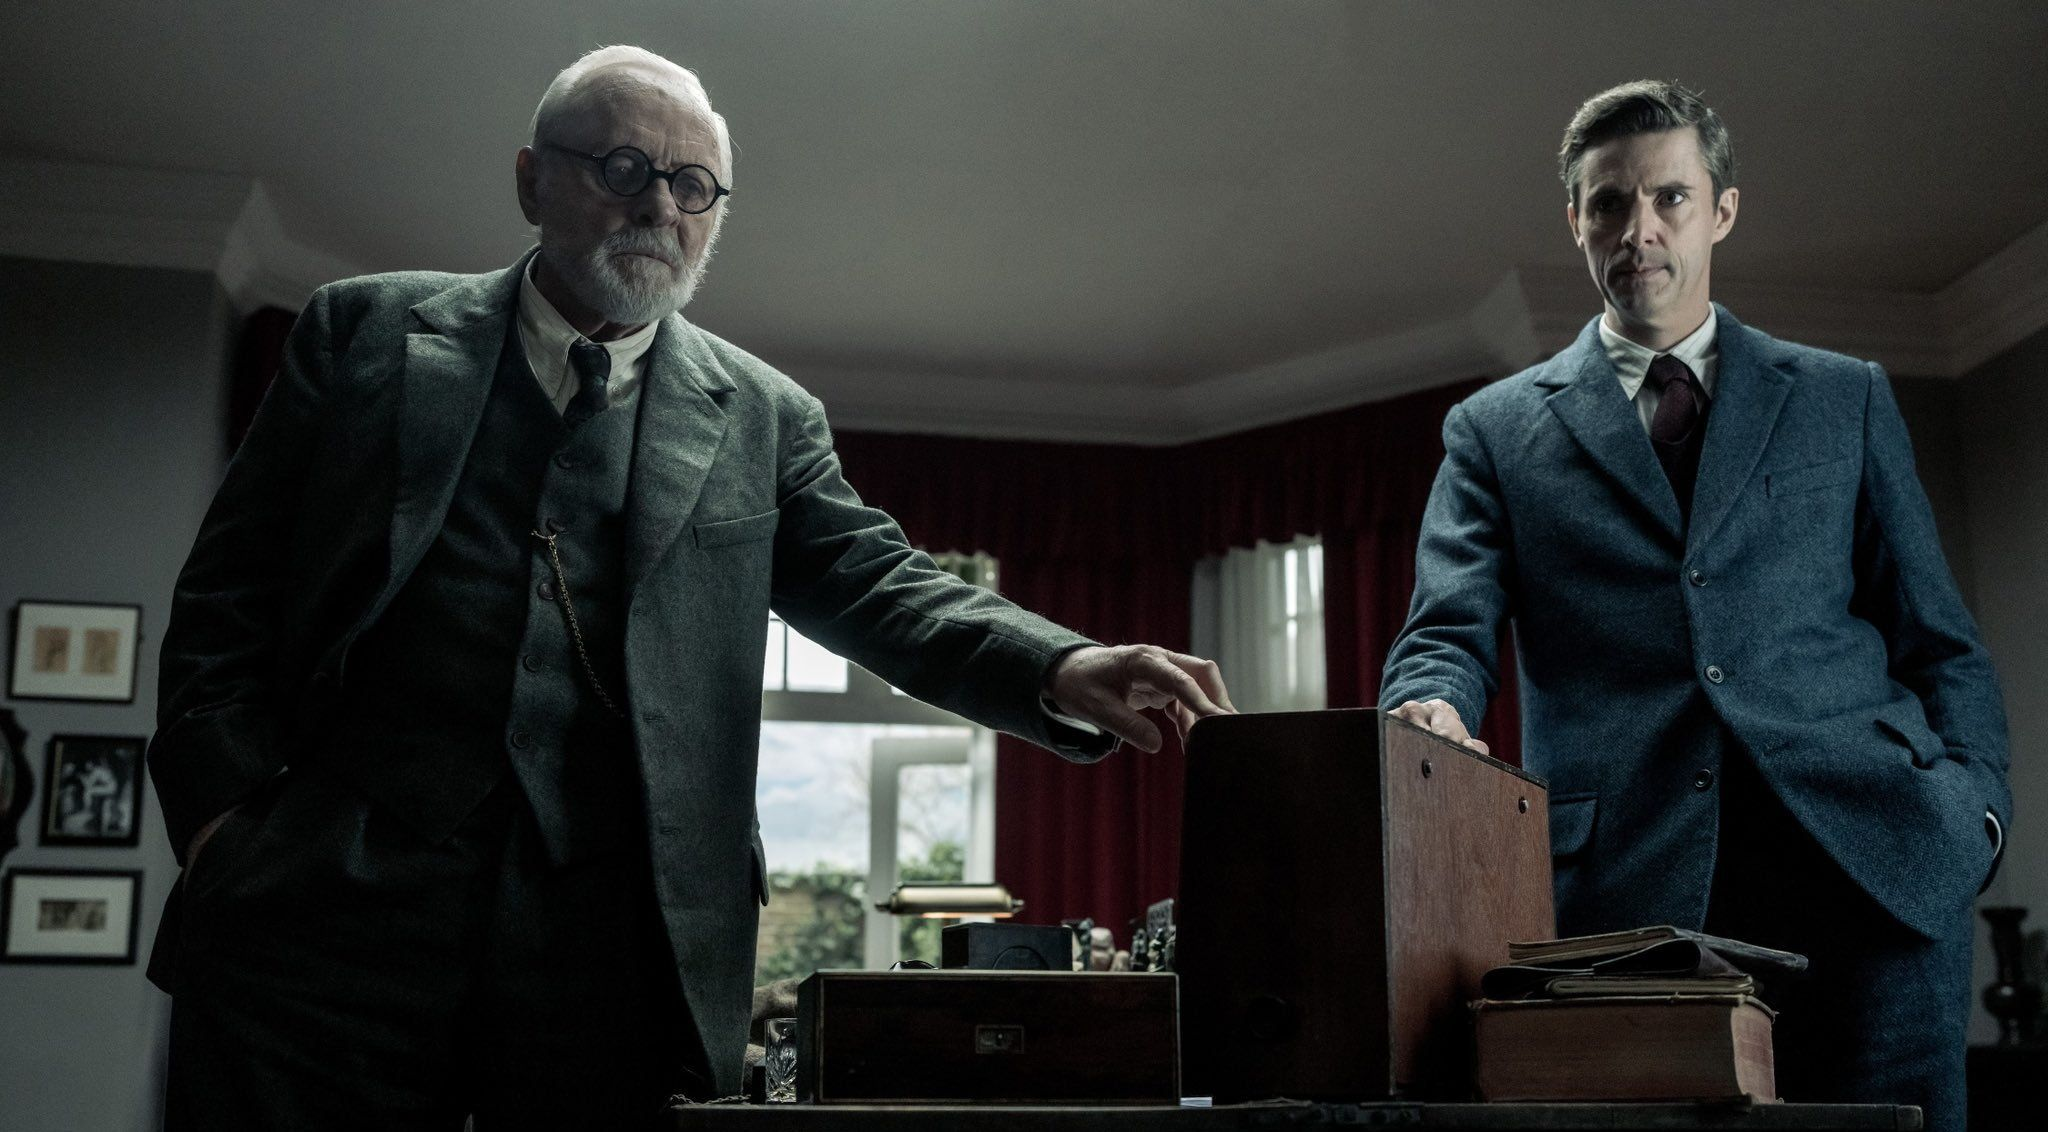What is the mood of the scene? The mood of the scene is tense and serious. The expressions on the faces of both men suggest a confrontation or a deep discussion. The dark suits, the subdued lighting, and the red curtains contribute to the overall dramatic and somber atmosphere. 